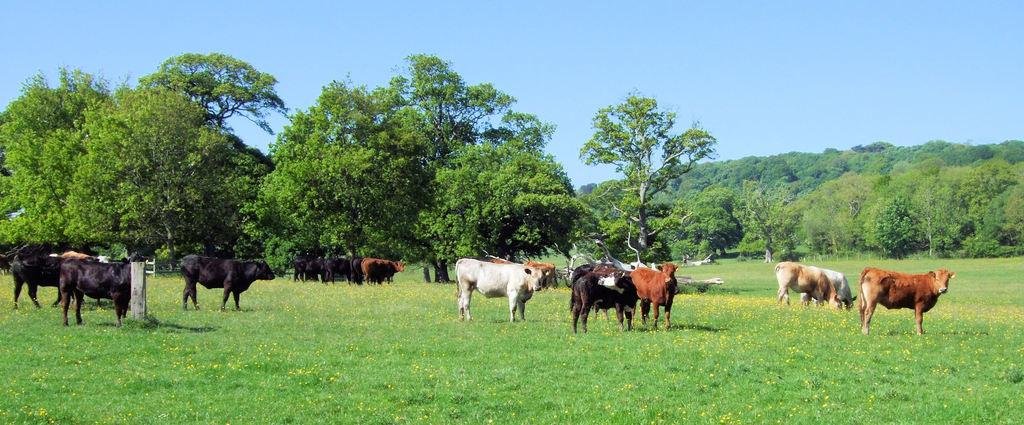What type of animals can be seen in the image? There is a group of animals in the image. What is the terrain like where the animals are located? The animals are on grassy land. What type of vegetation is present in the image? There are flowers on the plants in the image. What can be seen in the background of the image? There are groups of trees behind the animals. What is visible at the top of the image? The sky is visible at the top of the image. What type of riddle can be solved by the animals in the image? There is no riddle present in the image, nor is there any indication that the animals are solving a riddle. What type of wax is used to create the flowers in the image? The flowers in the image are not made of wax; they are real flowers growing on plants. 